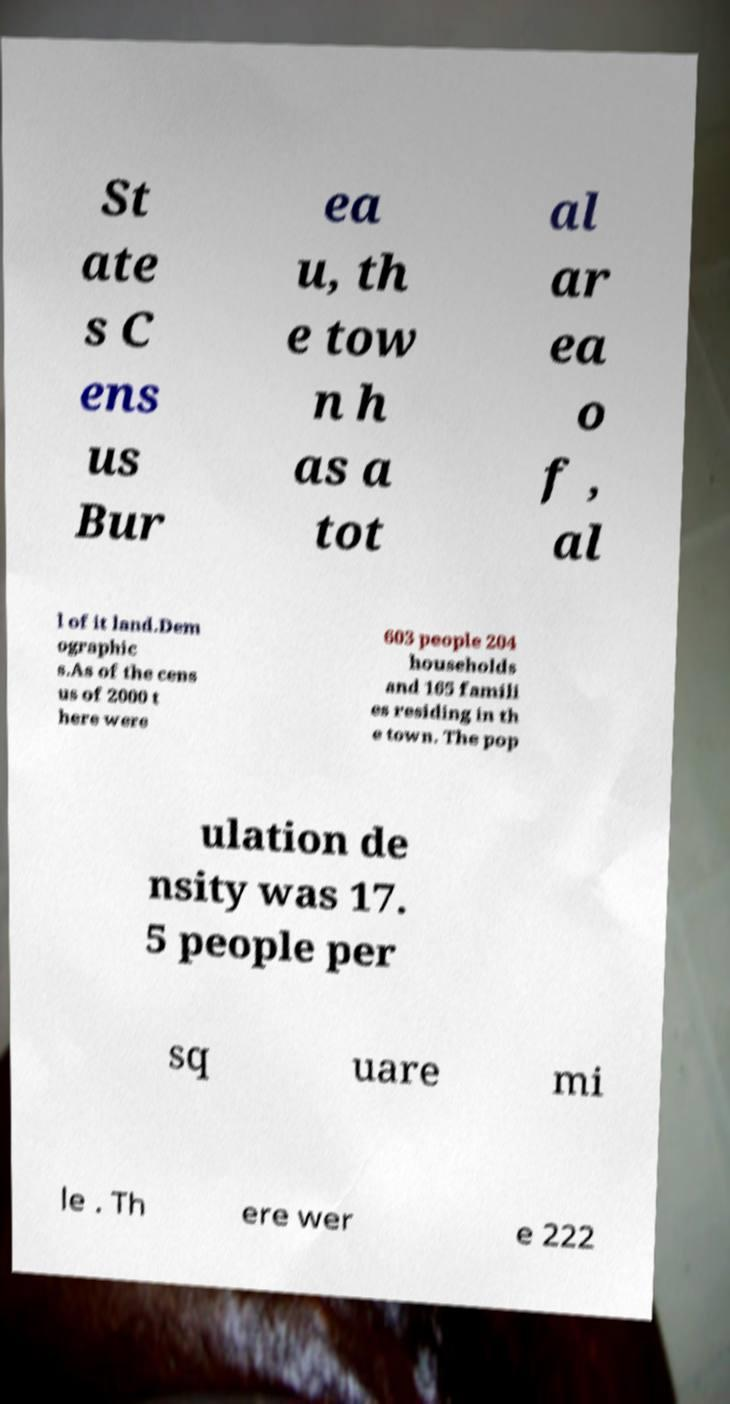There's text embedded in this image that I need extracted. Can you transcribe it verbatim? St ate s C ens us Bur ea u, th e tow n h as a tot al ar ea o f , al l of it land.Dem ographic s.As of the cens us of 2000 t here were 603 people 204 households and 165 famili es residing in th e town. The pop ulation de nsity was 17. 5 people per sq uare mi le . Th ere wer e 222 